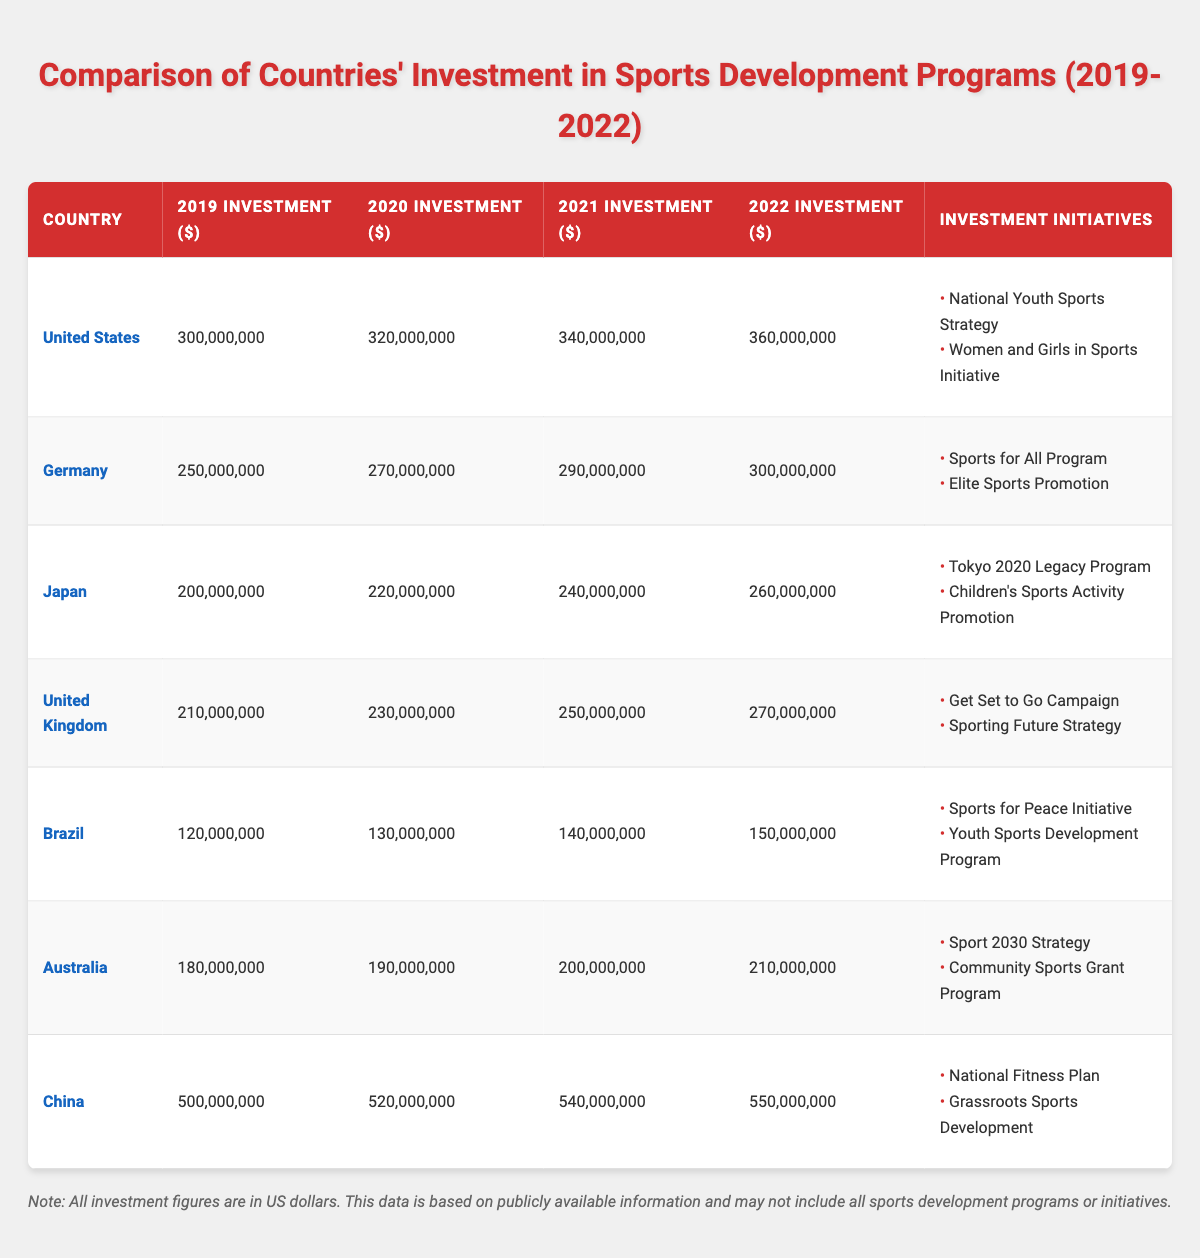What was the highest investment in sports development among the listed countries in 2022? Looking at the table, China had the highest investment in 2022, with an amount of $550,000,000.
Answer: $550,000,000 Which country saw the largest increase in investment from 2019 to 2022? To find this, we calculate the difference in investments: United States (360,000,000 - 300,000,000 = 60,000,000), Germany (300,000,000 - 250,000,000 = 50,000,000), Japan (260,000,000 - 200,000,000 = 60,000,000), United Kingdom (270,000,000 - 210,000,000 = 60,000,000), Brazil (150,000,000 - 120,000,000 = 30,000,000), Australia (210,000,000 - 180,000,000 = 30,000,000), and China (550,000,000 - 500,000,000 = 50,000,000). The largest increase is tied among the United States, Japan, and the United Kingdom, each with an increase of $60,000,000.
Answer: United States, Japan, and United Kingdom Did Brazil have a higher investment in 2021 or 2022? According to the table, Brazil's investment in 2021 was $140,000,000 and in 2022 it was $150,000,000. Therefore, the investment in 2022 was higher.
Answer: Yes What was the total investment of Japan over the four years from 2019 to 2022? To find the total, we add the investments: 200,000,000 + 220,000,000 + 240,000,000 + 260,000,000 = 920,000,000.
Answer: $920,000,000 Which country had the lowest investment in 2019? Referring to the table, Brazil had the lowest investment in 2019 at $120,000,000.
Answer: Brazil How much did China invest in sports development in 2020 compared to the United States? China's investment in 2020 was $520,000,000, while the United States invested $320,000,000. By comparing both, we see that China's investment was significantly higher than that of the United States.
Answer: Yes Which country had the most investment initiatives listed? All countries listed have two initiatives, therefore, there is no single country with more initiatives than the others.
Answer: None What was the average investment per year for Australia from 2019 to 2022? We find the sum of Australia's investments: 180,000,000 + 190,000,000 + 200,000,000 + 210,000,000 = 780,000,000. Dividing this total by the number of years (4 years) gives us an average of 780,000,000 / 4 = 195,000,000.
Answer: $195,000,000 